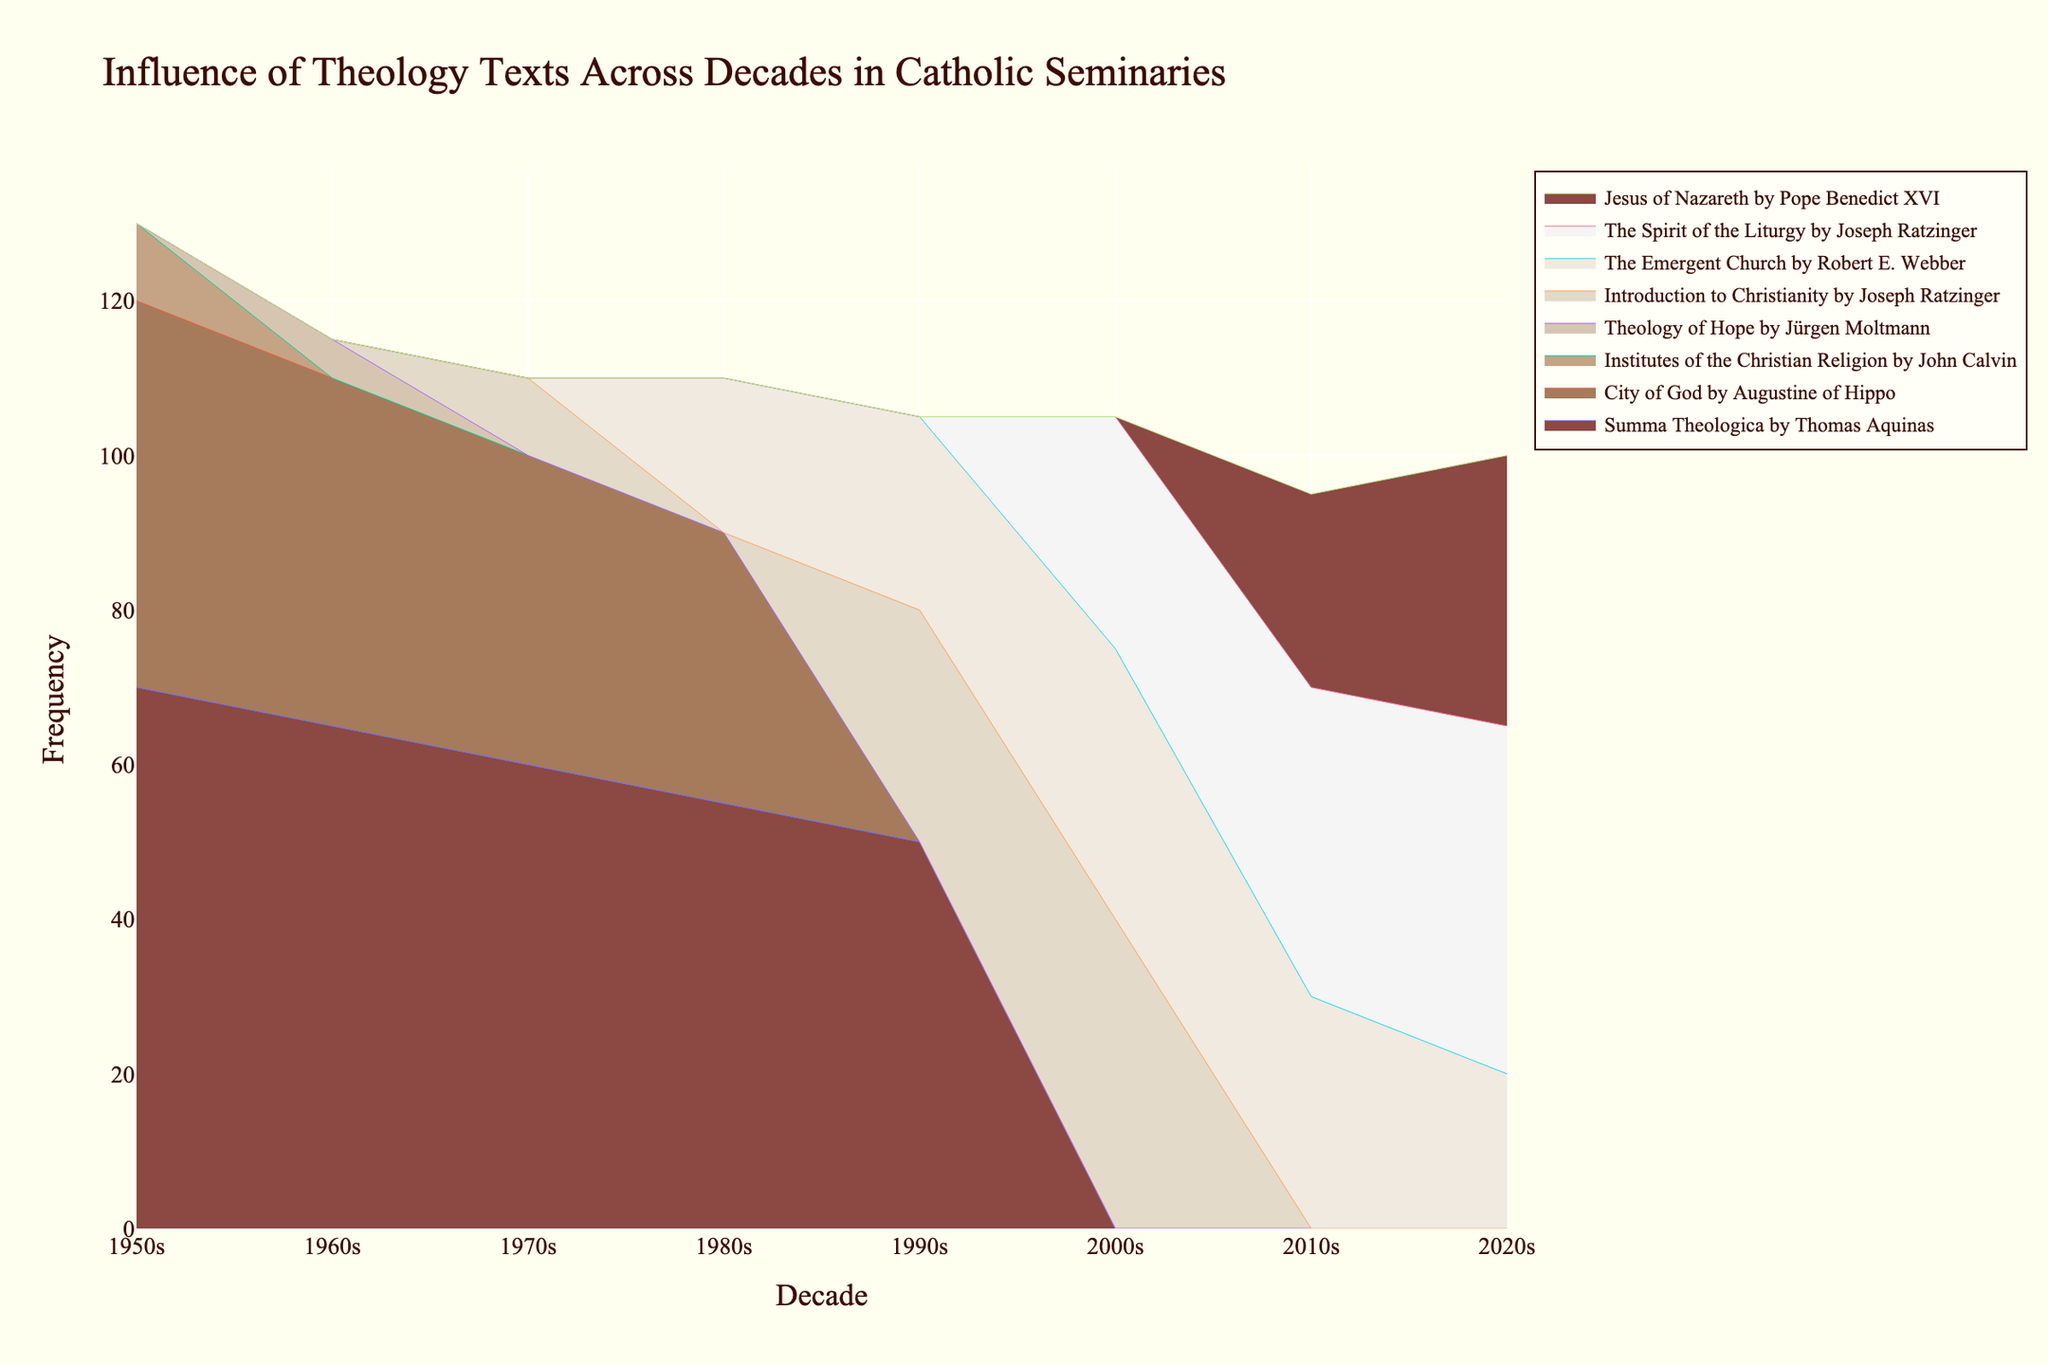What's the most referenced theological text during the 1950s? The most referenced text can be identified by looking at the stack height during the 1950s. "Summa Theologica by Thomas Aquinas" has the highest frequency.
Answer: Summa Theologica by Thomas Aquinas Which decade saw a notable increase in references to "Introduction to Christianity by Joseph Ratzinger"? By analyzing the graph, we can observe a significant increase in the area attributed to "Introduction to Christianity by Joseph Ratzinger" starting in the 1990s and further increasing in the 2000s.
Answer: 2000s What is the difference in the number of references to "Summa Theologica by Thomas Aquinas" between the 1950s and the 2020s? The frequency of references in the 1950s is 70, and in the 2020s, "Summa Theologica by Thomas Aquinas" is not listed, meaning the frequency is 0. The difference is 70 - 0 = 70.
Answer: 70 Which author has multiple texts referenced in the 2010s? By reviewing the 2010s section, we see that Joseph Ratzinger has two texts: "The Spirit of the Liturgy" and "Jesus of Nazareth."
Answer: Joseph Ratzinger How does the influence of "The Emergent Church by Robert E. Webber" change from the 1980s to the 2020s? The influence starts at 20 in the 1980s, increases to 30 in the 2010s, and then decreases to 20 in the 2020s.
Answer: It first increases, then decreases What trend can be observed for the "Summa Theologica by Thomas Aquinas" from the 1950s to the 1980s? The graph shows a decline in references: from 70 in the 1950s, to 65 in the 1960s, to 60 in the 1970s, and reaching 55 in the 1980s.
Answer: Declining trend In which decade did "City of God by Augustine of Hippo" have its lowest frequency of references? The lowest frequency can be found by comparing the stack heights of "City of God by Augustine of Hippo" across decades. The lowest value is 35 in the 1980s.
Answer: 1980s Which texts have disappeared from the references by the 2020s compared to the 1950s? By cross-examining the texts in the 1950s and 2020s, we see the "Summa Theologica by Thomas Aquinas," "City of God by Augustine of Hippo," and "Institutes of the Christian Religion by John Calvin" disappear by the 2020s.
Answer: Summa Theologica by Thomas Aquinas, City of God by Augustine of Hippo, Institutes of the Christian Religion by John Calvin How has the representation of Augustine of Hippo's texts changed over the decades? From the 1950s (50), the references decreased to 45 in the 1960s, 40 in the 1970s, and finally 35 in the 1980s, after which it no longer appears.
Answer: Decreased and then disappeared Which text shows a continuous increase in references from its introduction up to the 2020s? The text "The Spirit of the Liturgy by Joseph Ratzinger" shows a continuous increase: introduced in the 2000s (30), increased in the 2010s (40), and further in the 2020s (45).
Answer: The Spirit of the Liturgy by Joseph Ratzinger 